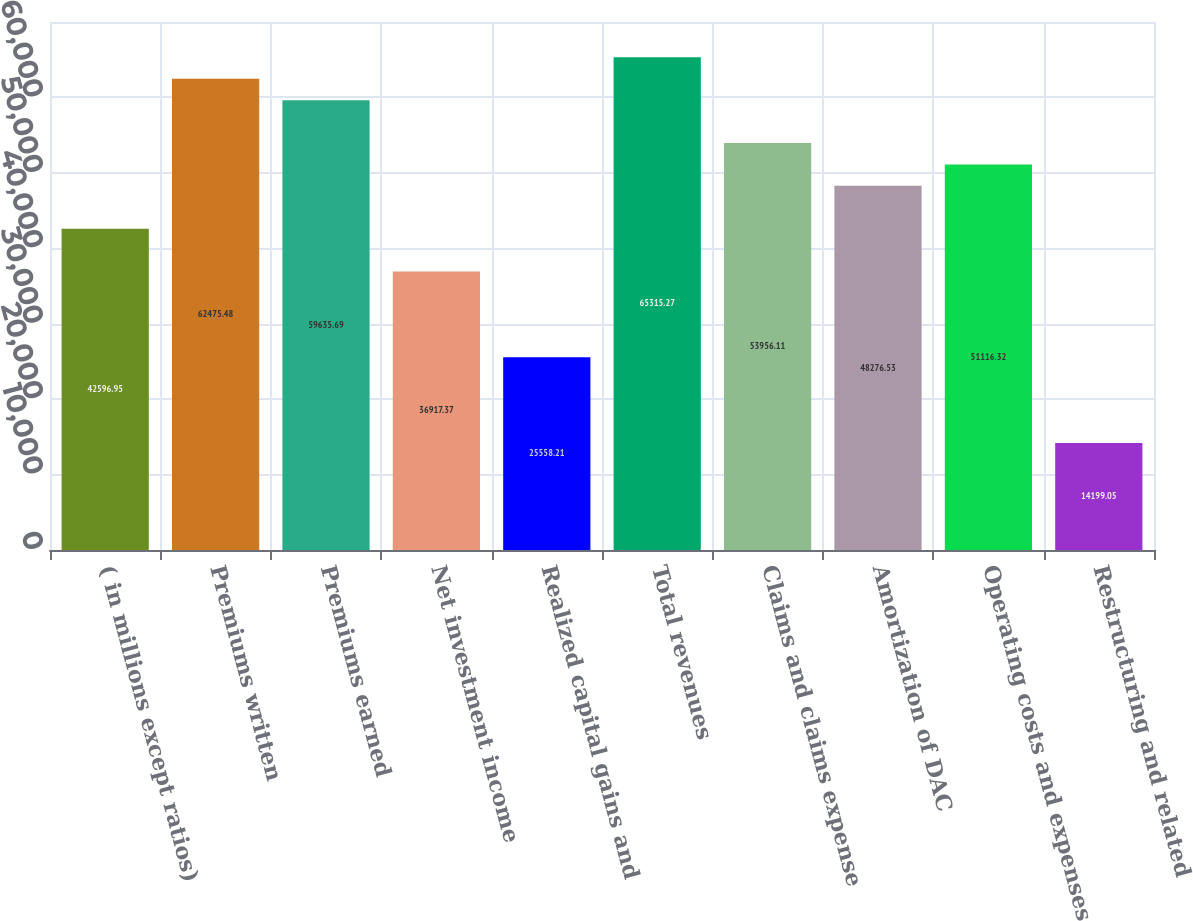<chart> <loc_0><loc_0><loc_500><loc_500><bar_chart><fcel>( in millions except ratios)<fcel>Premiums written<fcel>Premiums earned<fcel>Net investment income<fcel>Realized capital gains and<fcel>Total revenues<fcel>Claims and claims expense<fcel>Amortization of DAC<fcel>Operating costs and expenses<fcel>Restructuring and related<nl><fcel>42596.9<fcel>62475.5<fcel>59635.7<fcel>36917.4<fcel>25558.2<fcel>65315.3<fcel>53956.1<fcel>48276.5<fcel>51116.3<fcel>14199<nl></chart> 